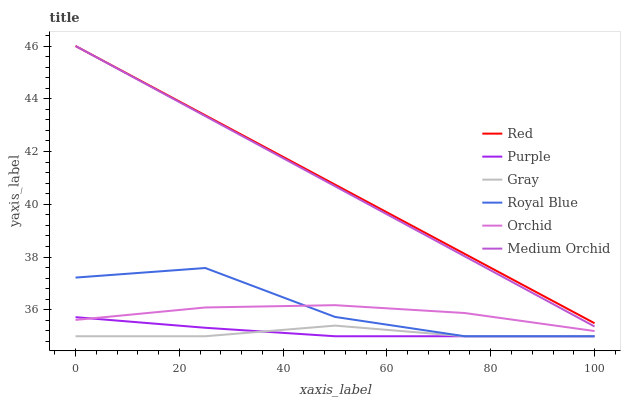Does Gray have the minimum area under the curve?
Answer yes or no. Yes. Does Red have the maximum area under the curve?
Answer yes or no. Yes. Does Purple have the minimum area under the curve?
Answer yes or no. No. Does Purple have the maximum area under the curve?
Answer yes or no. No. Is Medium Orchid the smoothest?
Answer yes or no. Yes. Is Royal Blue the roughest?
Answer yes or no. Yes. Is Purple the smoothest?
Answer yes or no. No. Is Purple the roughest?
Answer yes or no. No. Does Gray have the lowest value?
Answer yes or no. Yes. Does Medium Orchid have the lowest value?
Answer yes or no. No. Does Red have the highest value?
Answer yes or no. Yes. Does Purple have the highest value?
Answer yes or no. No. Is Gray less than Medium Orchid?
Answer yes or no. Yes. Is Medium Orchid greater than Orchid?
Answer yes or no. Yes. Does Purple intersect Gray?
Answer yes or no. Yes. Is Purple less than Gray?
Answer yes or no. No. Is Purple greater than Gray?
Answer yes or no. No. Does Gray intersect Medium Orchid?
Answer yes or no. No. 